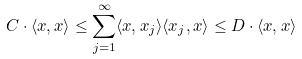<formula> <loc_0><loc_0><loc_500><loc_500>C \cdot \langle x , x \rangle \leq \sum _ { j = 1 } ^ { \infty } \langle x , x _ { j } \rangle \langle x _ { j } , x \rangle \leq D \cdot \langle x , x \rangle</formula> 